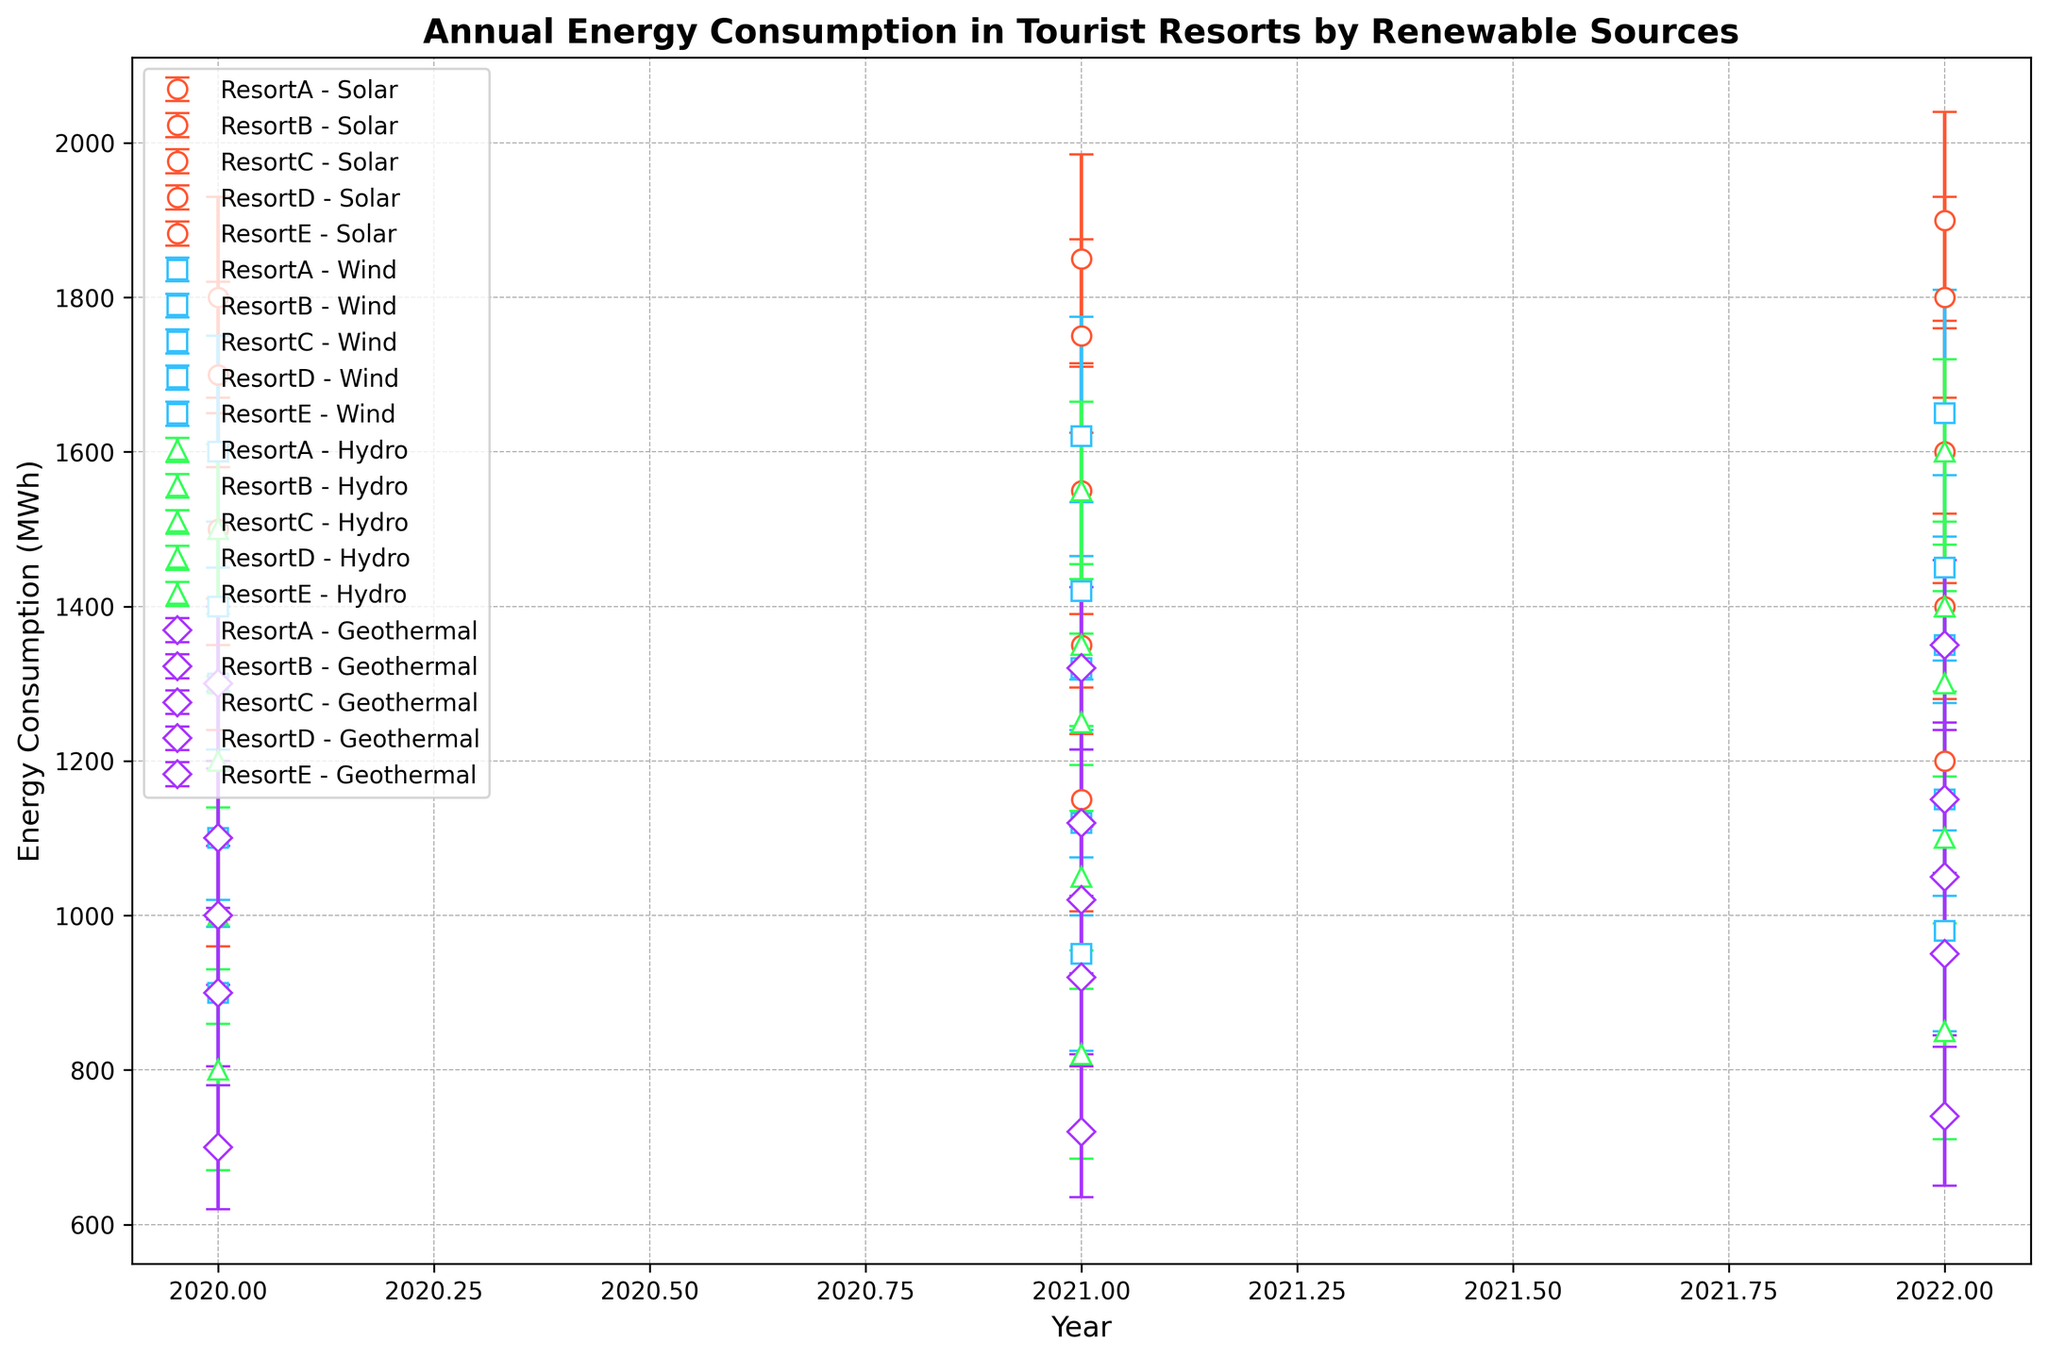Which resort had the highest solar energy consumption in 2022? Look for the resort with the highest point on the solar energy line for the year 2022. Resort C shows the highest value for solar energy consumption in that year.
Answer: Resort C Which resort saw the biggest increase in wind energy consumption from 2020 to 2022? Compare the wind energy consumption points between 2020 and 2022 for each resort and find the largest difference. Resort A increased from 1300 MWh in 2020 to 1450 MWh in 2022, a difference of 150 MWh, which is the largest.
Answer: Resort A What is the average annual hydro energy consumption for Resort E from 2020 to 2022? Sum the hydro energy consumption values for Resort E in 2020, 2021, and 2022 (1000 + 1050 + 1100 = 3150 MWh) and then divide by 3 to find the average. 3150 / 3 = 1050 MWh.
Answer: 1050 MWh For which renewable source does Resort B show the lowest standard deviation across all three years? Look at the error bars (which represent standard deviation) for Resort B across the years for each energy type and identify the one with the lowest overall error bars. GeothermalEnergyStdDev is consistently lower compared to the others.
Answer: Geothermal Between Solar and Geothermal energy, which one had a higher average consumption in Resort D over the years presented? Calculate the average consumption for Resort D over 2020-2022 for both Solar and Geothermal then compare. Solar: (1700 + 1750 + 1800) / 3 = 1750; Geothermal: (1100 + 1120 + 1150) / 3 = 1123.33. Solar has a higher average.
Answer: Solar Which year did Resort C see the smallest difference between solar and wind energy consumption? Calculate the difference between solar and wind energy consumption for Resort C in each year and identify the year with the smallest difference: 2020 (1800 - 1600 = 200), 2021 (1850 - 1620 = 230), 2022 (1900 - 1650 = 250). The smallest difference is in 2020.
Answer: 2020 Does any resort show a consistent increase in hydro energy consumption from 2020 to 2022? Review the hydro energy consumption values from 2020 to 2022 for each resort and check for a constant increase each year. Resort E shows consistent increases: 2020 (1000 MWh), 2021 (1050 MWh), 2022 (1100 MWh).
Answer: Resort E How much did the average solar energy consumption of Resort A change from 2020 to 2022? Subtract the 2020 solar energy consumption from the 2022 solar energy consumption for Resort A and divide by the number of years for the average increase per year. (1600 - 1500 MWh) / 2 years = 50 MWh per year.
Answer: 50 MWh per year 